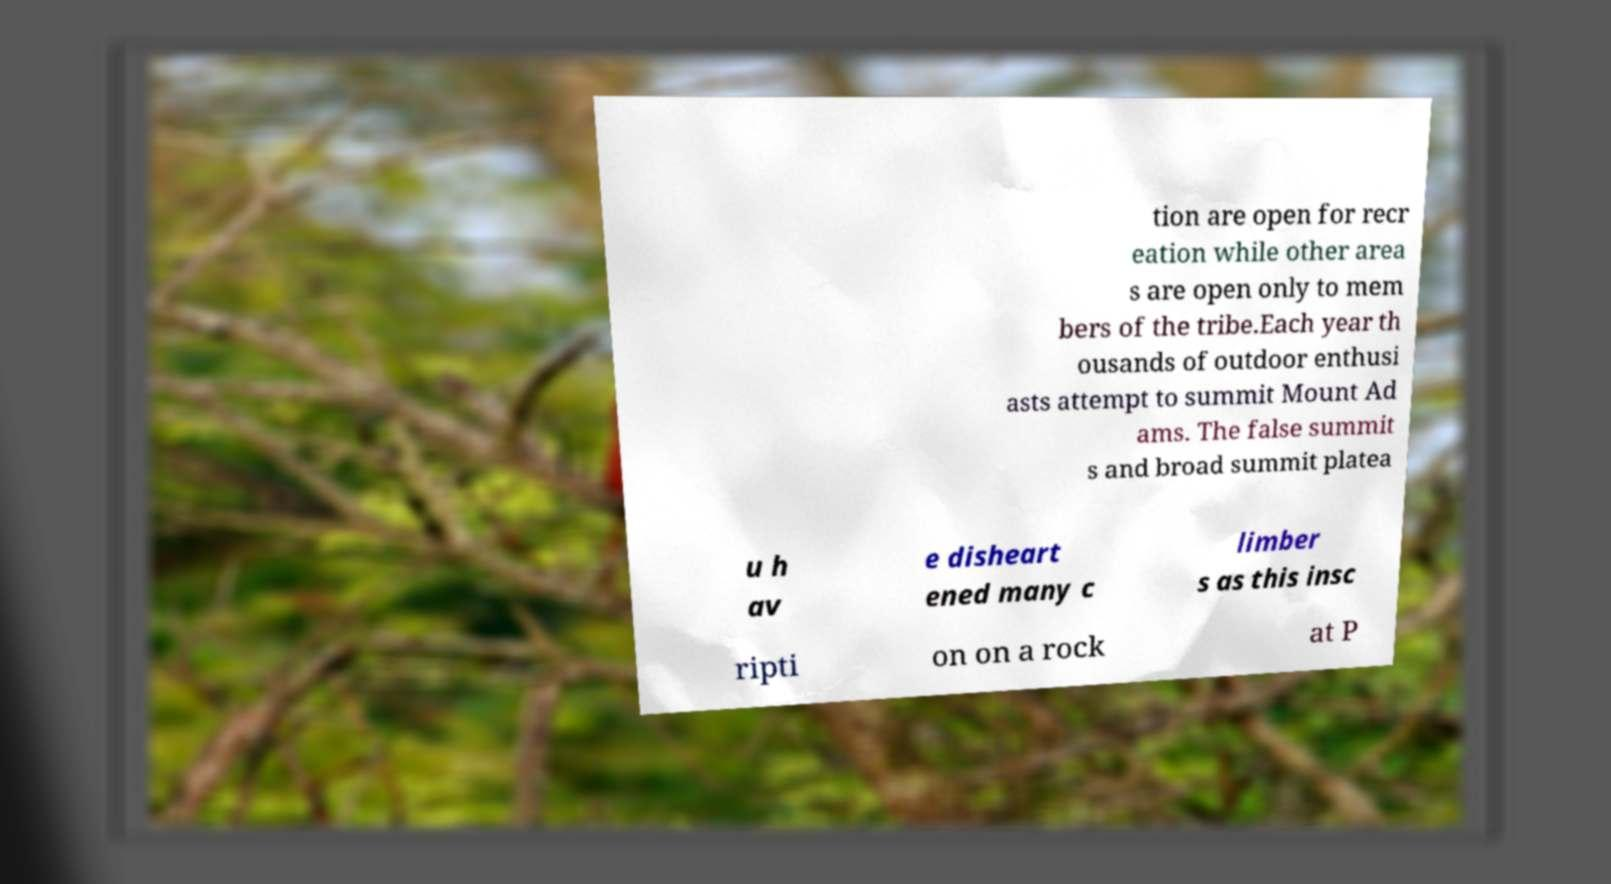Can you accurately transcribe the text from the provided image for me? tion are open for recr eation while other area s are open only to mem bers of the tribe.Each year th ousands of outdoor enthusi asts attempt to summit Mount Ad ams. The false summit s and broad summit platea u h av e disheart ened many c limber s as this insc ripti on on a rock at P 